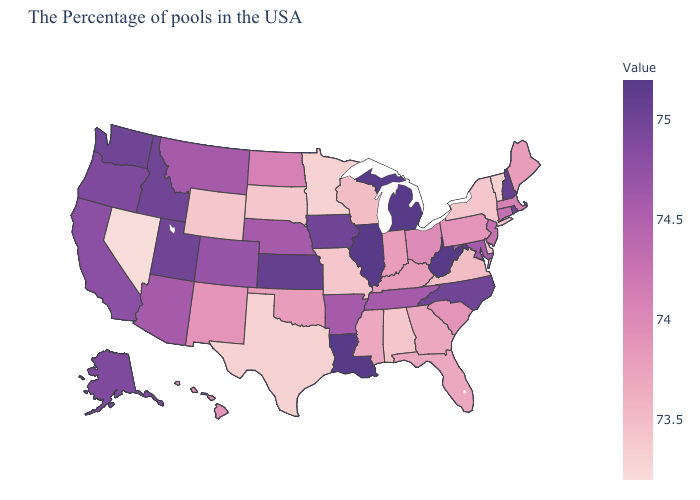Which states have the highest value in the USA?
Write a very short answer. West Virginia, Michigan, Illinois, Louisiana. Which states have the highest value in the USA?
Quick response, please. West Virginia, Michigan, Illinois, Louisiana. Which states have the lowest value in the USA?
Answer briefly. Nevada. Does New Hampshire have the highest value in the Northeast?
Keep it brief. Yes. Does Oregon have a lower value than South Carolina?
Keep it brief. No. 